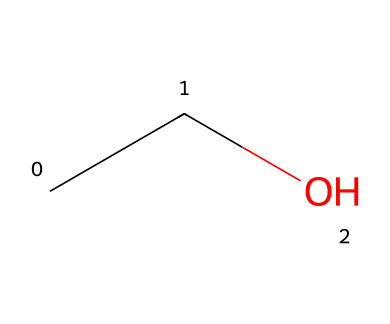What is the molecular formula of this compound? The SMILES representation "CCO" indicates two carbon atoms (C), six hydrogen atoms (H), and one oxygen atom (O). The molecular formula is derived from counting the atoms in the structure.
Answer: C2H6O How many atoms are present in this molecule? Counting the carbon, hydrogen, and oxygen atoms from the SMILES representation "CCO", we have a total of two carbon atoms, six hydrogen atoms, and one oxygen atom, leading to a total of nine atoms.
Answer: 9 What type of alcohol is represented by this structure? The molecule with the structure "CCO" is ethanol, which is a simple alcohol. It is classified as a primary alcohol because the carbon bonded to the hydroxyl group is also bonded to only one other carbon atom.
Answer: primary How many bonds are present in this molecule? In the structure represented by "CCO", there are a total of seven bonds: five C-H bonds, one C-C bond, and one C-O bond. The count results from analyzing the connections between the atoms.
Answer: 7 Does this compound have any functional groups? The presence of the hydroxyl group (-OH) in the compound "CCO" indicates that it contains a functional group that characterizes alcohols. This specific group is responsible for alcohol's properties.
Answer: yes What kind of isomerism can this compound exhibit? Ethanol can exhibit structural isomerism due to the presence of different structural forms, but since "CCO" specifically represents ethanol, it does not have positional isomers or stereoisomers. This leads to identifying it as having no isomers in this representation.
Answer: none What is the primary use of this type of compound in beverages like wine? Ethanol is primarily known for its role as an intoxicating ingredient in alcoholic beverages, including wine. It originates from the fermentation process of sugars by yeast, and it contributes to the flavor and effects of the drink.
Answer: intoxicating 